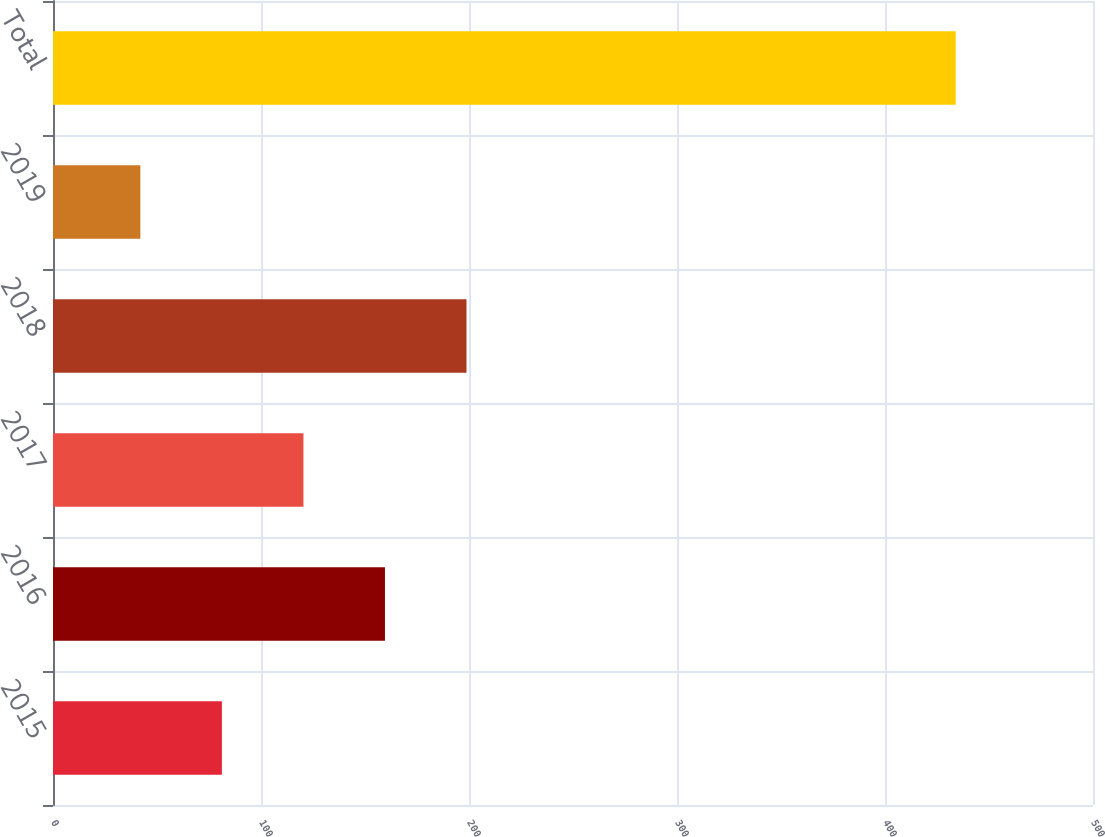<chart> <loc_0><loc_0><loc_500><loc_500><bar_chart><fcel>2015<fcel>2016<fcel>2017<fcel>2018<fcel>2019<fcel>Total<nl><fcel>81.2<fcel>159.6<fcel>120.4<fcel>198.8<fcel>42<fcel>434<nl></chart> 